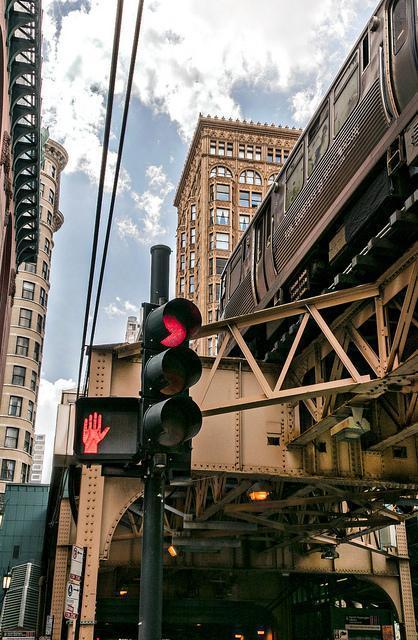How many buses can you see?
Give a very brief answer. 1. How many people are wearing glasses in this image?
Give a very brief answer. 0. 